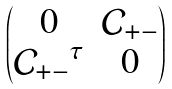Convert formula to latex. <formula><loc_0><loc_0><loc_500><loc_500>\begin{pmatrix} 0 & \mathcal { C } _ { + - } \\ { \mathcal { C } _ { + - } } ^ { \tau } & 0 \end{pmatrix}</formula> 